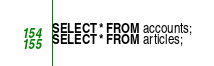<code> <loc_0><loc_0><loc_500><loc_500><_SQL_>SELECT * FROM accounts;
SELECT * FROM articles;</code> 